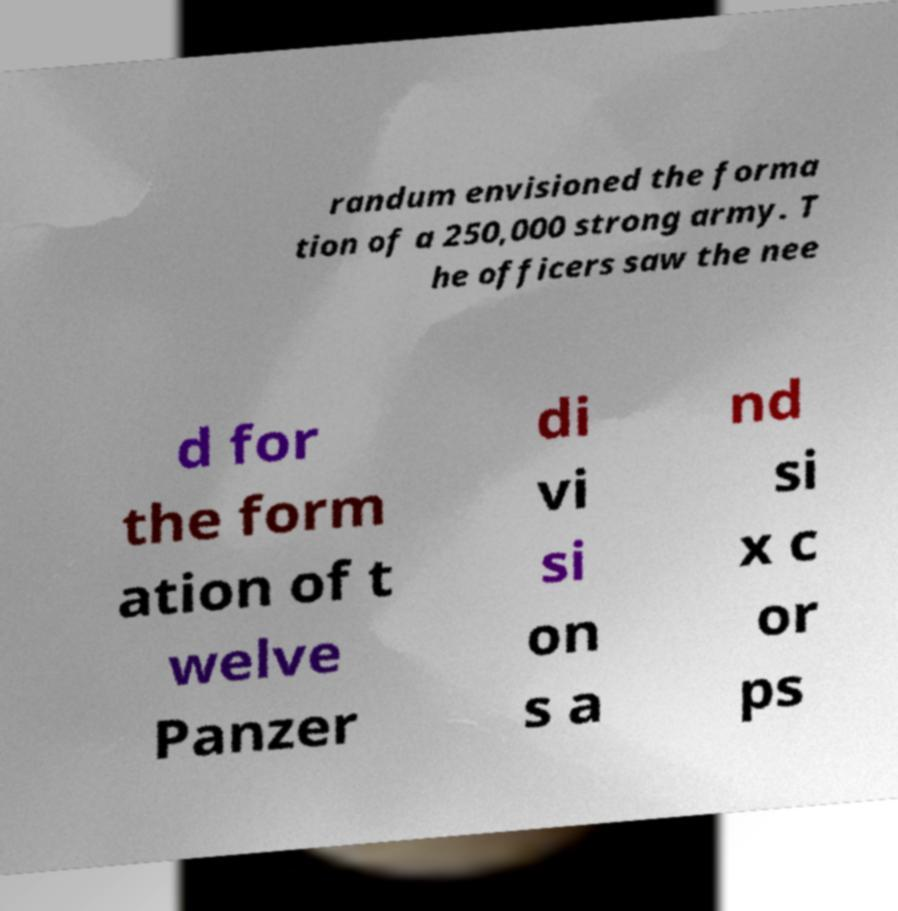Please identify and transcribe the text found in this image. randum envisioned the forma tion of a 250,000 strong army. T he officers saw the nee d for the form ation of t welve Panzer di vi si on s a nd si x c or ps 